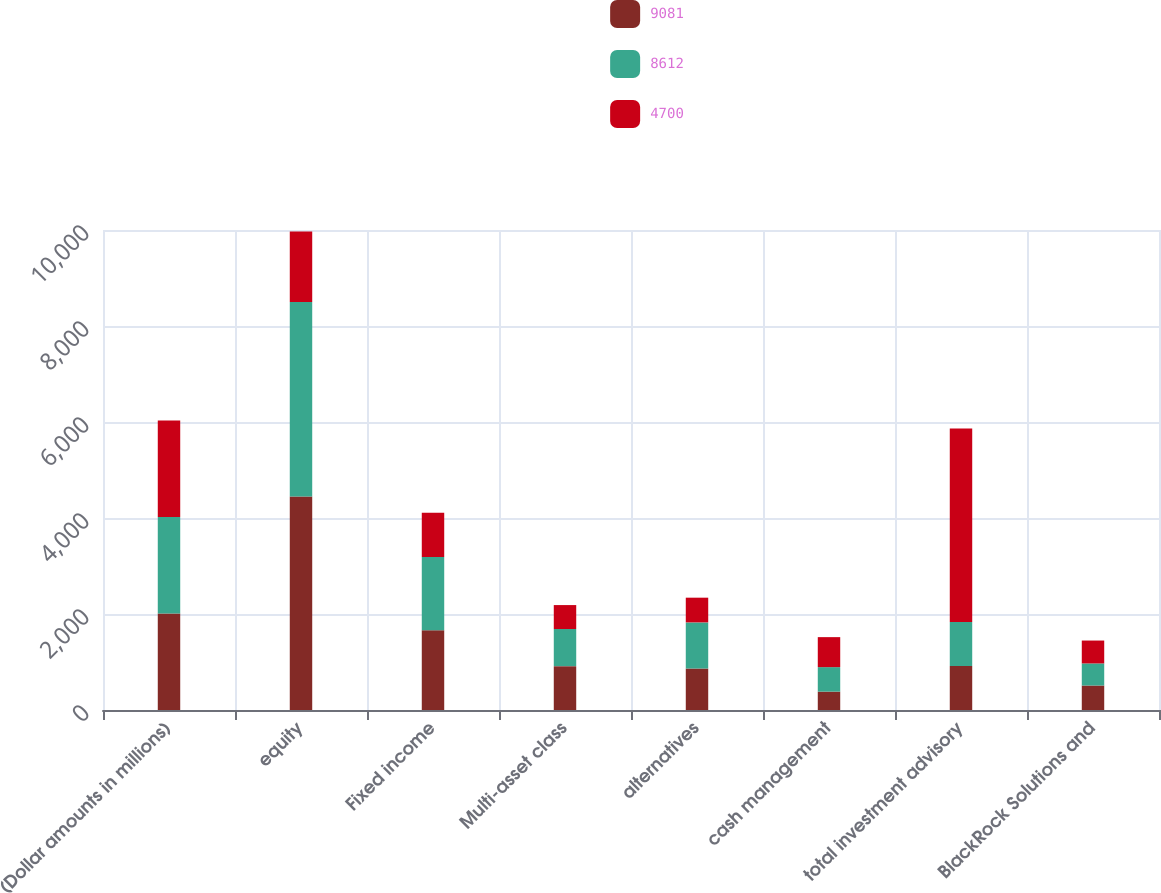Convert chart to OTSL. <chart><loc_0><loc_0><loc_500><loc_500><stacked_bar_chart><ecel><fcel>(Dollar amounts in millions)<fcel>equity<fcel>Fixed income<fcel>Multi-asset class<fcel>alternatives<fcel>cash management<fcel>total investment advisory<fcel>BlackRock Solutions and<nl><fcel>9081<fcel>2011<fcel>4447<fcel>1659<fcel>914<fcel>864<fcel>383<fcel>917.5<fcel>510<nl><fcel>8612<fcel>2010<fcel>4055<fcel>1531<fcel>773<fcel>961<fcel>510<fcel>917.5<fcel>460<nl><fcel>4700<fcel>2009<fcel>1468<fcel>921<fcel>499<fcel>515<fcel>625<fcel>4028<fcel>477<nl></chart> 